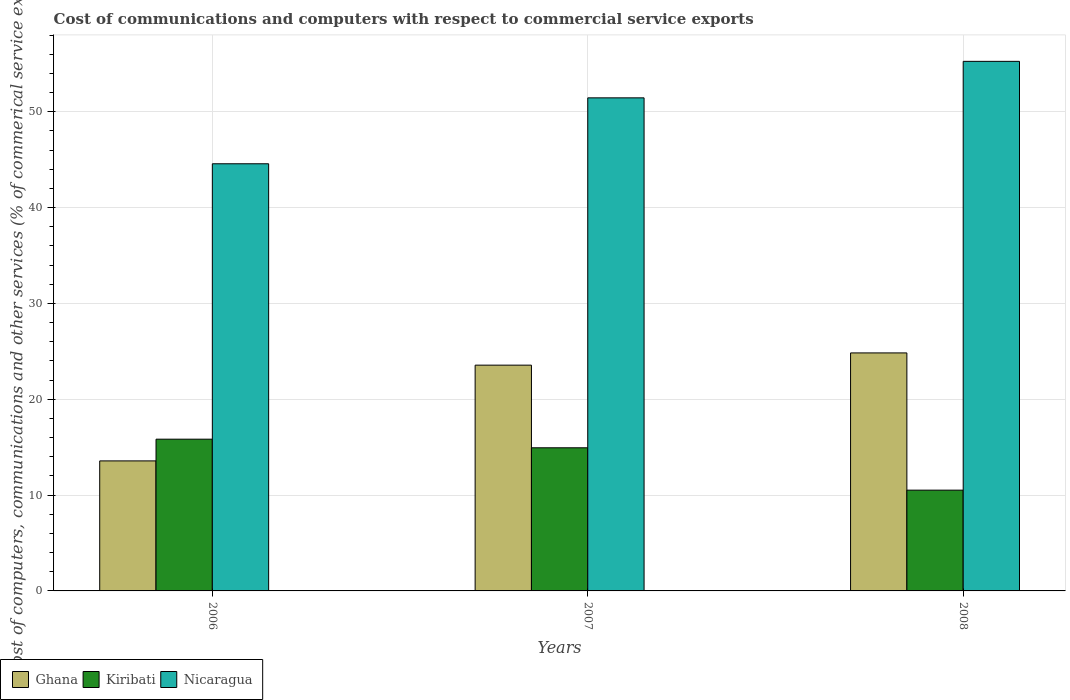How many different coloured bars are there?
Keep it short and to the point. 3. How many groups of bars are there?
Offer a very short reply. 3. Are the number of bars per tick equal to the number of legend labels?
Make the answer very short. Yes. Are the number of bars on each tick of the X-axis equal?
Provide a short and direct response. Yes. How many bars are there on the 1st tick from the left?
Offer a terse response. 3. How many bars are there on the 2nd tick from the right?
Make the answer very short. 3. In how many cases, is the number of bars for a given year not equal to the number of legend labels?
Provide a short and direct response. 0. What is the cost of communications and computers in Nicaragua in 2007?
Offer a very short reply. 51.46. Across all years, what is the maximum cost of communications and computers in Kiribati?
Your answer should be compact. 15.83. Across all years, what is the minimum cost of communications and computers in Nicaragua?
Your response must be concise. 44.58. In which year was the cost of communications and computers in Kiribati maximum?
Your response must be concise. 2006. What is the total cost of communications and computers in Ghana in the graph?
Keep it short and to the point. 61.97. What is the difference between the cost of communications and computers in Ghana in 2006 and that in 2007?
Provide a short and direct response. -9.99. What is the difference between the cost of communications and computers in Nicaragua in 2008 and the cost of communications and computers in Ghana in 2006?
Give a very brief answer. 41.69. What is the average cost of communications and computers in Ghana per year?
Offer a terse response. 20.66. In the year 2008, what is the difference between the cost of communications and computers in Kiribati and cost of communications and computers in Nicaragua?
Make the answer very short. -44.75. What is the ratio of the cost of communications and computers in Ghana in 2006 to that in 2008?
Give a very brief answer. 0.55. Is the cost of communications and computers in Ghana in 2006 less than that in 2007?
Your answer should be very brief. Yes. What is the difference between the highest and the second highest cost of communications and computers in Ghana?
Offer a very short reply. 1.28. What is the difference between the highest and the lowest cost of communications and computers in Kiribati?
Your response must be concise. 5.32. In how many years, is the cost of communications and computers in Nicaragua greater than the average cost of communications and computers in Nicaragua taken over all years?
Ensure brevity in your answer.  2. What does the 1st bar from the left in 2006 represents?
Keep it short and to the point. Ghana. What does the 3rd bar from the right in 2008 represents?
Give a very brief answer. Ghana. Is it the case that in every year, the sum of the cost of communications and computers in Ghana and cost of communications and computers in Kiribati is greater than the cost of communications and computers in Nicaragua?
Make the answer very short. No. How many bars are there?
Make the answer very short. 9. Are all the bars in the graph horizontal?
Keep it short and to the point. No. What is the difference between two consecutive major ticks on the Y-axis?
Offer a terse response. 10. Does the graph contain any zero values?
Offer a very short reply. No. Does the graph contain grids?
Provide a short and direct response. Yes. Where does the legend appear in the graph?
Ensure brevity in your answer.  Bottom left. What is the title of the graph?
Make the answer very short. Cost of communications and computers with respect to commercial service exports. What is the label or title of the Y-axis?
Ensure brevity in your answer.  Cost of computers, communications and other services (% of commerical service exports). What is the Cost of computers, communications and other services (% of commerical service exports) of Ghana in 2006?
Offer a very short reply. 13.57. What is the Cost of computers, communications and other services (% of commerical service exports) of Kiribati in 2006?
Your answer should be very brief. 15.83. What is the Cost of computers, communications and other services (% of commerical service exports) in Nicaragua in 2006?
Provide a succinct answer. 44.58. What is the Cost of computers, communications and other services (% of commerical service exports) in Ghana in 2007?
Your answer should be very brief. 23.56. What is the Cost of computers, communications and other services (% of commerical service exports) of Kiribati in 2007?
Give a very brief answer. 14.94. What is the Cost of computers, communications and other services (% of commerical service exports) of Nicaragua in 2007?
Your response must be concise. 51.46. What is the Cost of computers, communications and other services (% of commerical service exports) of Ghana in 2008?
Offer a very short reply. 24.84. What is the Cost of computers, communications and other services (% of commerical service exports) of Kiribati in 2008?
Your answer should be very brief. 10.52. What is the Cost of computers, communications and other services (% of commerical service exports) of Nicaragua in 2008?
Your response must be concise. 55.26. Across all years, what is the maximum Cost of computers, communications and other services (% of commerical service exports) of Ghana?
Your answer should be compact. 24.84. Across all years, what is the maximum Cost of computers, communications and other services (% of commerical service exports) in Kiribati?
Keep it short and to the point. 15.83. Across all years, what is the maximum Cost of computers, communications and other services (% of commerical service exports) of Nicaragua?
Provide a succinct answer. 55.26. Across all years, what is the minimum Cost of computers, communications and other services (% of commerical service exports) of Ghana?
Offer a very short reply. 13.57. Across all years, what is the minimum Cost of computers, communications and other services (% of commerical service exports) in Kiribati?
Provide a succinct answer. 10.52. Across all years, what is the minimum Cost of computers, communications and other services (% of commerical service exports) of Nicaragua?
Provide a short and direct response. 44.58. What is the total Cost of computers, communications and other services (% of commerical service exports) in Ghana in the graph?
Offer a terse response. 61.97. What is the total Cost of computers, communications and other services (% of commerical service exports) of Kiribati in the graph?
Provide a short and direct response. 41.29. What is the total Cost of computers, communications and other services (% of commerical service exports) in Nicaragua in the graph?
Give a very brief answer. 151.29. What is the difference between the Cost of computers, communications and other services (% of commerical service exports) in Ghana in 2006 and that in 2007?
Ensure brevity in your answer.  -9.99. What is the difference between the Cost of computers, communications and other services (% of commerical service exports) in Kiribati in 2006 and that in 2007?
Your answer should be very brief. 0.9. What is the difference between the Cost of computers, communications and other services (% of commerical service exports) of Nicaragua in 2006 and that in 2007?
Your answer should be compact. -6.88. What is the difference between the Cost of computers, communications and other services (% of commerical service exports) of Ghana in 2006 and that in 2008?
Your answer should be very brief. -11.27. What is the difference between the Cost of computers, communications and other services (% of commerical service exports) in Kiribati in 2006 and that in 2008?
Offer a terse response. 5.32. What is the difference between the Cost of computers, communications and other services (% of commerical service exports) of Nicaragua in 2006 and that in 2008?
Your answer should be very brief. -10.69. What is the difference between the Cost of computers, communications and other services (% of commerical service exports) of Ghana in 2007 and that in 2008?
Offer a terse response. -1.28. What is the difference between the Cost of computers, communications and other services (% of commerical service exports) of Kiribati in 2007 and that in 2008?
Give a very brief answer. 4.42. What is the difference between the Cost of computers, communications and other services (% of commerical service exports) of Nicaragua in 2007 and that in 2008?
Your answer should be compact. -3.81. What is the difference between the Cost of computers, communications and other services (% of commerical service exports) of Ghana in 2006 and the Cost of computers, communications and other services (% of commerical service exports) of Kiribati in 2007?
Your response must be concise. -1.37. What is the difference between the Cost of computers, communications and other services (% of commerical service exports) of Ghana in 2006 and the Cost of computers, communications and other services (% of commerical service exports) of Nicaragua in 2007?
Offer a terse response. -37.89. What is the difference between the Cost of computers, communications and other services (% of commerical service exports) of Kiribati in 2006 and the Cost of computers, communications and other services (% of commerical service exports) of Nicaragua in 2007?
Offer a very short reply. -35.62. What is the difference between the Cost of computers, communications and other services (% of commerical service exports) of Ghana in 2006 and the Cost of computers, communications and other services (% of commerical service exports) of Kiribati in 2008?
Provide a short and direct response. 3.05. What is the difference between the Cost of computers, communications and other services (% of commerical service exports) of Ghana in 2006 and the Cost of computers, communications and other services (% of commerical service exports) of Nicaragua in 2008?
Offer a terse response. -41.69. What is the difference between the Cost of computers, communications and other services (% of commerical service exports) of Kiribati in 2006 and the Cost of computers, communications and other services (% of commerical service exports) of Nicaragua in 2008?
Your response must be concise. -39.43. What is the difference between the Cost of computers, communications and other services (% of commerical service exports) in Ghana in 2007 and the Cost of computers, communications and other services (% of commerical service exports) in Kiribati in 2008?
Your response must be concise. 13.04. What is the difference between the Cost of computers, communications and other services (% of commerical service exports) of Ghana in 2007 and the Cost of computers, communications and other services (% of commerical service exports) of Nicaragua in 2008?
Your answer should be very brief. -31.7. What is the difference between the Cost of computers, communications and other services (% of commerical service exports) of Kiribati in 2007 and the Cost of computers, communications and other services (% of commerical service exports) of Nicaragua in 2008?
Ensure brevity in your answer.  -40.33. What is the average Cost of computers, communications and other services (% of commerical service exports) of Ghana per year?
Ensure brevity in your answer.  20.66. What is the average Cost of computers, communications and other services (% of commerical service exports) in Kiribati per year?
Provide a short and direct response. 13.76. What is the average Cost of computers, communications and other services (% of commerical service exports) in Nicaragua per year?
Give a very brief answer. 50.43. In the year 2006, what is the difference between the Cost of computers, communications and other services (% of commerical service exports) in Ghana and Cost of computers, communications and other services (% of commerical service exports) in Kiribati?
Provide a short and direct response. -2.27. In the year 2006, what is the difference between the Cost of computers, communications and other services (% of commerical service exports) of Ghana and Cost of computers, communications and other services (% of commerical service exports) of Nicaragua?
Your response must be concise. -31.01. In the year 2006, what is the difference between the Cost of computers, communications and other services (% of commerical service exports) in Kiribati and Cost of computers, communications and other services (% of commerical service exports) in Nicaragua?
Ensure brevity in your answer.  -28.74. In the year 2007, what is the difference between the Cost of computers, communications and other services (% of commerical service exports) in Ghana and Cost of computers, communications and other services (% of commerical service exports) in Kiribati?
Offer a very short reply. 8.62. In the year 2007, what is the difference between the Cost of computers, communications and other services (% of commerical service exports) in Ghana and Cost of computers, communications and other services (% of commerical service exports) in Nicaragua?
Offer a terse response. -27.89. In the year 2007, what is the difference between the Cost of computers, communications and other services (% of commerical service exports) of Kiribati and Cost of computers, communications and other services (% of commerical service exports) of Nicaragua?
Give a very brief answer. -36.52. In the year 2008, what is the difference between the Cost of computers, communications and other services (% of commerical service exports) of Ghana and Cost of computers, communications and other services (% of commerical service exports) of Kiribati?
Ensure brevity in your answer.  14.32. In the year 2008, what is the difference between the Cost of computers, communications and other services (% of commerical service exports) of Ghana and Cost of computers, communications and other services (% of commerical service exports) of Nicaragua?
Keep it short and to the point. -30.43. In the year 2008, what is the difference between the Cost of computers, communications and other services (% of commerical service exports) of Kiribati and Cost of computers, communications and other services (% of commerical service exports) of Nicaragua?
Provide a succinct answer. -44.75. What is the ratio of the Cost of computers, communications and other services (% of commerical service exports) of Ghana in 2006 to that in 2007?
Make the answer very short. 0.58. What is the ratio of the Cost of computers, communications and other services (% of commerical service exports) in Kiribati in 2006 to that in 2007?
Keep it short and to the point. 1.06. What is the ratio of the Cost of computers, communications and other services (% of commerical service exports) in Nicaragua in 2006 to that in 2007?
Your answer should be compact. 0.87. What is the ratio of the Cost of computers, communications and other services (% of commerical service exports) of Ghana in 2006 to that in 2008?
Make the answer very short. 0.55. What is the ratio of the Cost of computers, communications and other services (% of commerical service exports) in Kiribati in 2006 to that in 2008?
Your answer should be compact. 1.51. What is the ratio of the Cost of computers, communications and other services (% of commerical service exports) of Nicaragua in 2006 to that in 2008?
Your answer should be very brief. 0.81. What is the ratio of the Cost of computers, communications and other services (% of commerical service exports) of Ghana in 2007 to that in 2008?
Provide a short and direct response. 0.95. What is the ratio of the Cost of computers, communications and other services (% of commerical service exports) of Kiribati in 2007 to that in 2008?
Your answer should be compact. 1.42. What is the ratio of the Cost of computers, communications and other services (% of commerical service exports) in Nicaragua in 2007 to that in 2008?
Ensure brevity in your answer.  0.93. What is the difference between the highest and the second highest Cost of computers, communications and other services (% of commerical service exports) in Ghana?
Make the answer very short. 1.28. What is the difference between the highest and the second highest Cost of computers, communications and other services (% of commerical service exports) of Kiribati?
Offer a very short reply. 0.9. What is the difference between the highest and the second highest Cost of computers, communications and other services (% of commerical service exports) in Nicaragua?
Your answer should be very brief. 3.81. What is the difference between the highest and the lowest Cost of computers, communications and other services (% of commerical service exports) of Ghana?
Keep it short and to the point. 11.27. What is the difference between the highest and the lowest Cost of computers, communications and other services (% of commerical service exports) of Kiribati?
Your answer should be compact. 5.32. What is the difference between the highest and the lowest Cost of computers, communications and other services (% of commerical service exports) in Nicaragua?
Ensure brevity in your answer.  10.69. 